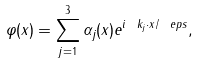<formula> <loc_0><loc_0><loc_500><loc_500>\varphi ( x ) = \sum _ { j = 1 } ^ { 3 } \alpha _ { j } ( x ) e ^ { i \ k _ { j } \cdot x / \ e p s } ,</formula> 